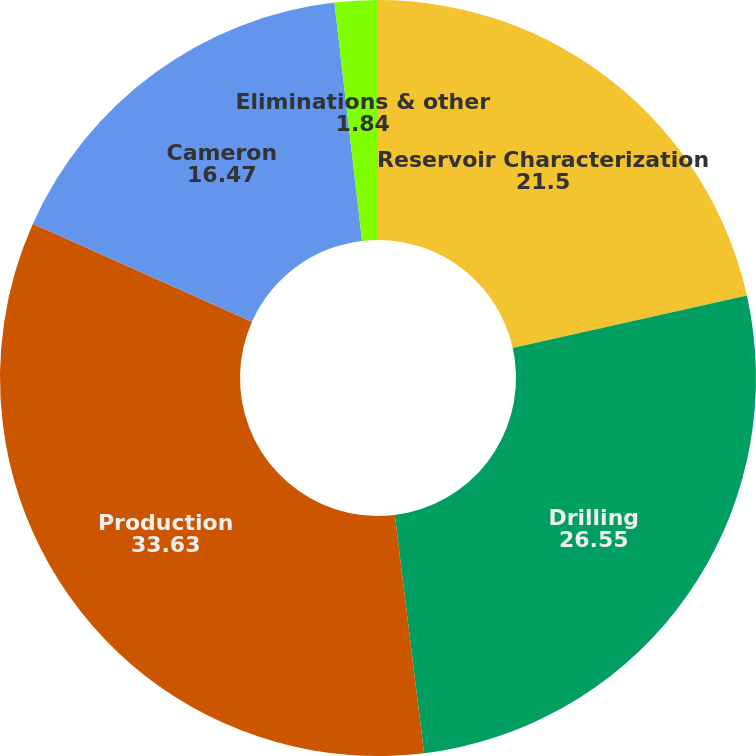Convert chart. <chart><loc_0><loc_0><loc_500><loc_500><pie_chart><fcel>Reservoir Characterization<fcel>Drilling<fcel>Production<fcel>Cameron<fcel>Eliminations & other<nl><fcel>21.5%<fcel>26.55%<fcel>33.63%<fcel>16.47%<fcel>1.84%<nl></chart> 